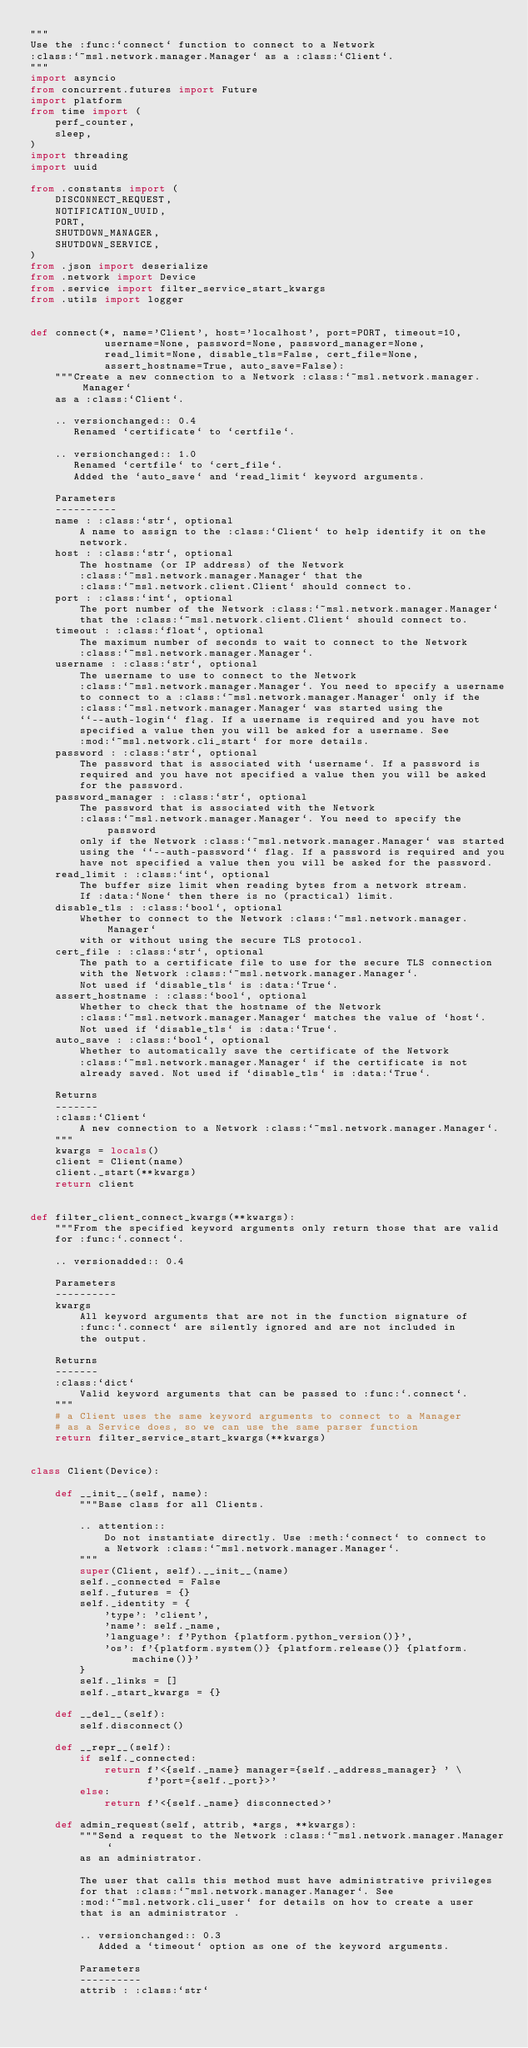<code> <loc_0><loc_0><loc_500><loc_500><_Python_>"""
Use the :func:`connect` function to connect to a Network
:class:`~msl.network.manager.Manager` as a :class:`Client`.
"""
import asyncio
from concurrent.futures import Future
import platform
from time import (
    perf_counter,
    sleep,
)
import threading
import uuid

from .constants import (
    DISCONNECT_REQUEST,
    NOTIFICATION_UUID,
    PORT,
    SHUTDOWN_MANAGER,
    SHUTDOWN_SERVICE,
)
from .json import deserialize
from .network import Device
from .service import filter_service_start_kwargs
from .utils import logger


def connect(*, name='Client', host='localhost', port=PORT, timeout=10,
            username=None, password=None, password_manager=None,
            read_limit=None, disable_tls=False, cert_file=None,
            assert_hostname=True, auto_save=False):
    """Create a new connection to a Network :class:`~msl.network.manager.Manager`
    as a :class:`Client`.

    .. versionchanged:: 0.4
       Renamed `certificate` to `certfile`.

    .. versionchanged:: 1.0
       Renamed `certfile` to `cert_file`.
       Added the `auto_save` and `read_limit` keyword arguments.

    Parameters
    ----------
    name : :class:`str`, optional
        A name to assign to the :class:`Client` to help identify it on the
        network.
    host : :class:`str`, optional
        The hostname (or IP address) of the Network
        :class:`~msl.network.manager.Manager` that the
        :class:`~msl.network.client.Client` should connect to.
    port : :class:`int`, optional
        The port number of the Network :class:`~msl.network.manager.Manager`
        that the :class:`~msl.network.client.Client` should connect to.
    timeout : :class:`float`, optional
        The maximum number of seconds to wait to connect to the Network
        :class:`~msl.network.manager.Manager`.
    username : :class:`str`, optional
        The username to use to connect to the Network
        :class:`~msl.network.manager.Manager`. You need to specify a username
        to connect to a :class:`~msl.network.manager.Manager` only if the
        :class:`~msl.network.manager.Manager` was started using the
        ``--auth-login`` flag. If a username is required and you have not
        specified a value then you will be asked for a username. See
        :mod:`~msl.network.cli_start` for more details.
    password : :class:`str`, optional
        The password that is associated with `username`. If a password is
        required and you have not specified a value then you will be asked
        for the password.
    password_manager : :class:`str`, optional
        The password that is associated with the Network
        :class:`~msl.network.manager.Manager`. You need to specify the password
        only if the Network :class:`~msl.network.manager.Manager` was started
        using the ``--auth-password`` flag. If a password is required and you
        have not specified a value then you will be asked for the password.
    read_limit : :class:`int`, optional
        The buffer size limit when reading bytes from a network stream.
        If :data:`None` then there is no (practical) limit.
    disable_tls : :class:`bool`, optional
        Whether to connect to the Network :class:`~msl.network.manager.Manager`
        with or without using the secure TLS protocol.
    cert_file : :class:`str`, optional
        The path to a certificate file to use for the secure TLS connection
        with the Network :class:`~msl.network.manager.Manager`.
        Not used if `disable_tls` is :data:`True`.
    assert_hostname : :class:`bool`, optional
        Whether to check that the hostname of the Network
        :class:`~msl.network.manager.Manager` matches the value of `host`.
        Not used if `disable_tls` is :data:`True`.
    auto_save : :class:`bool`, optional
        Whether to automatically save the certificate of the Network
        :class:`~msl.network.manager.Manager` if the certificate is not
        already saved. Not used if `disable_tls` is :data:`True`.

    Returns
    -------
    :class:`Client`
        A new connection to a Network :class:`~msl.network.manager.Manager`.
    """
    kwargs = locals()
    client = Client(name)
    client._start(**kwargs)
    return client


def filter_client_connect_kwargs(**kwargs):
    """From the specified keyword arguments only return those that are valid
    for :func:`.connect`.

    .. versionadded:: 0.4

    Parameters
    ----------
    kwargs
        All keyword arguments that are not in the function signature of
        :func:`.connect` are silently ignored and are not included in
        the output.

    Returns
    -------
    :class:`dict`
        Valid keyword arguments that can be passed to :func:`.connect`.
    """
    # a Client uses the same keyword arguments to connect to a Manager
    # as a Service does, so we can use the same parser function
    return filter_service_start_kwargs(**kwargs)


class Client(Device):

    def __init__(self, name):
        """Base class for all Clients.

        .. attention::
            Do not instantiate directly. Use :meth:`connect` to connect to
            a Network :class:`~msl.network.manager.Manager`.
        """
        super(Client, self).__init__(name)
        self._connected = False
        self._futures = {}
        self._identity = {
            'type': 'client',
            'name': self._name,
            'language': f'Python {platform.python_version()}',
            'os': f'{platform.system()} {platform.release()} {platform.machine()}'
        }
        self._links = []
        self._start_kwargs = {}

    def __del__(self):
        self.disconnect()

    def __repr__(self):
        if self._connected:
            return f'<{self._name} manager={self._address_manager} ' \
                   f'port={self._port}>'
        else:
            return f'<{self._name} disconnected>'

    def admin_request(self, attrib, *args, **kwargs):
        """Send a request to the Network :class:`~msl.network.manager.Manager`
        as an administrator.

        The user that calls this method must have administrative privileges
        for that :class:`~msl.network.manager.Manager`. See
        :mod:`~msl.network.cli_user` for details on how to create a user
        that is an administrator .

        .. versionchanged:: 0.3
           Added a `timeout` option as one of the keyword arguments.

        Parameters
        ----------
        attrib : :class:`str`</code> 